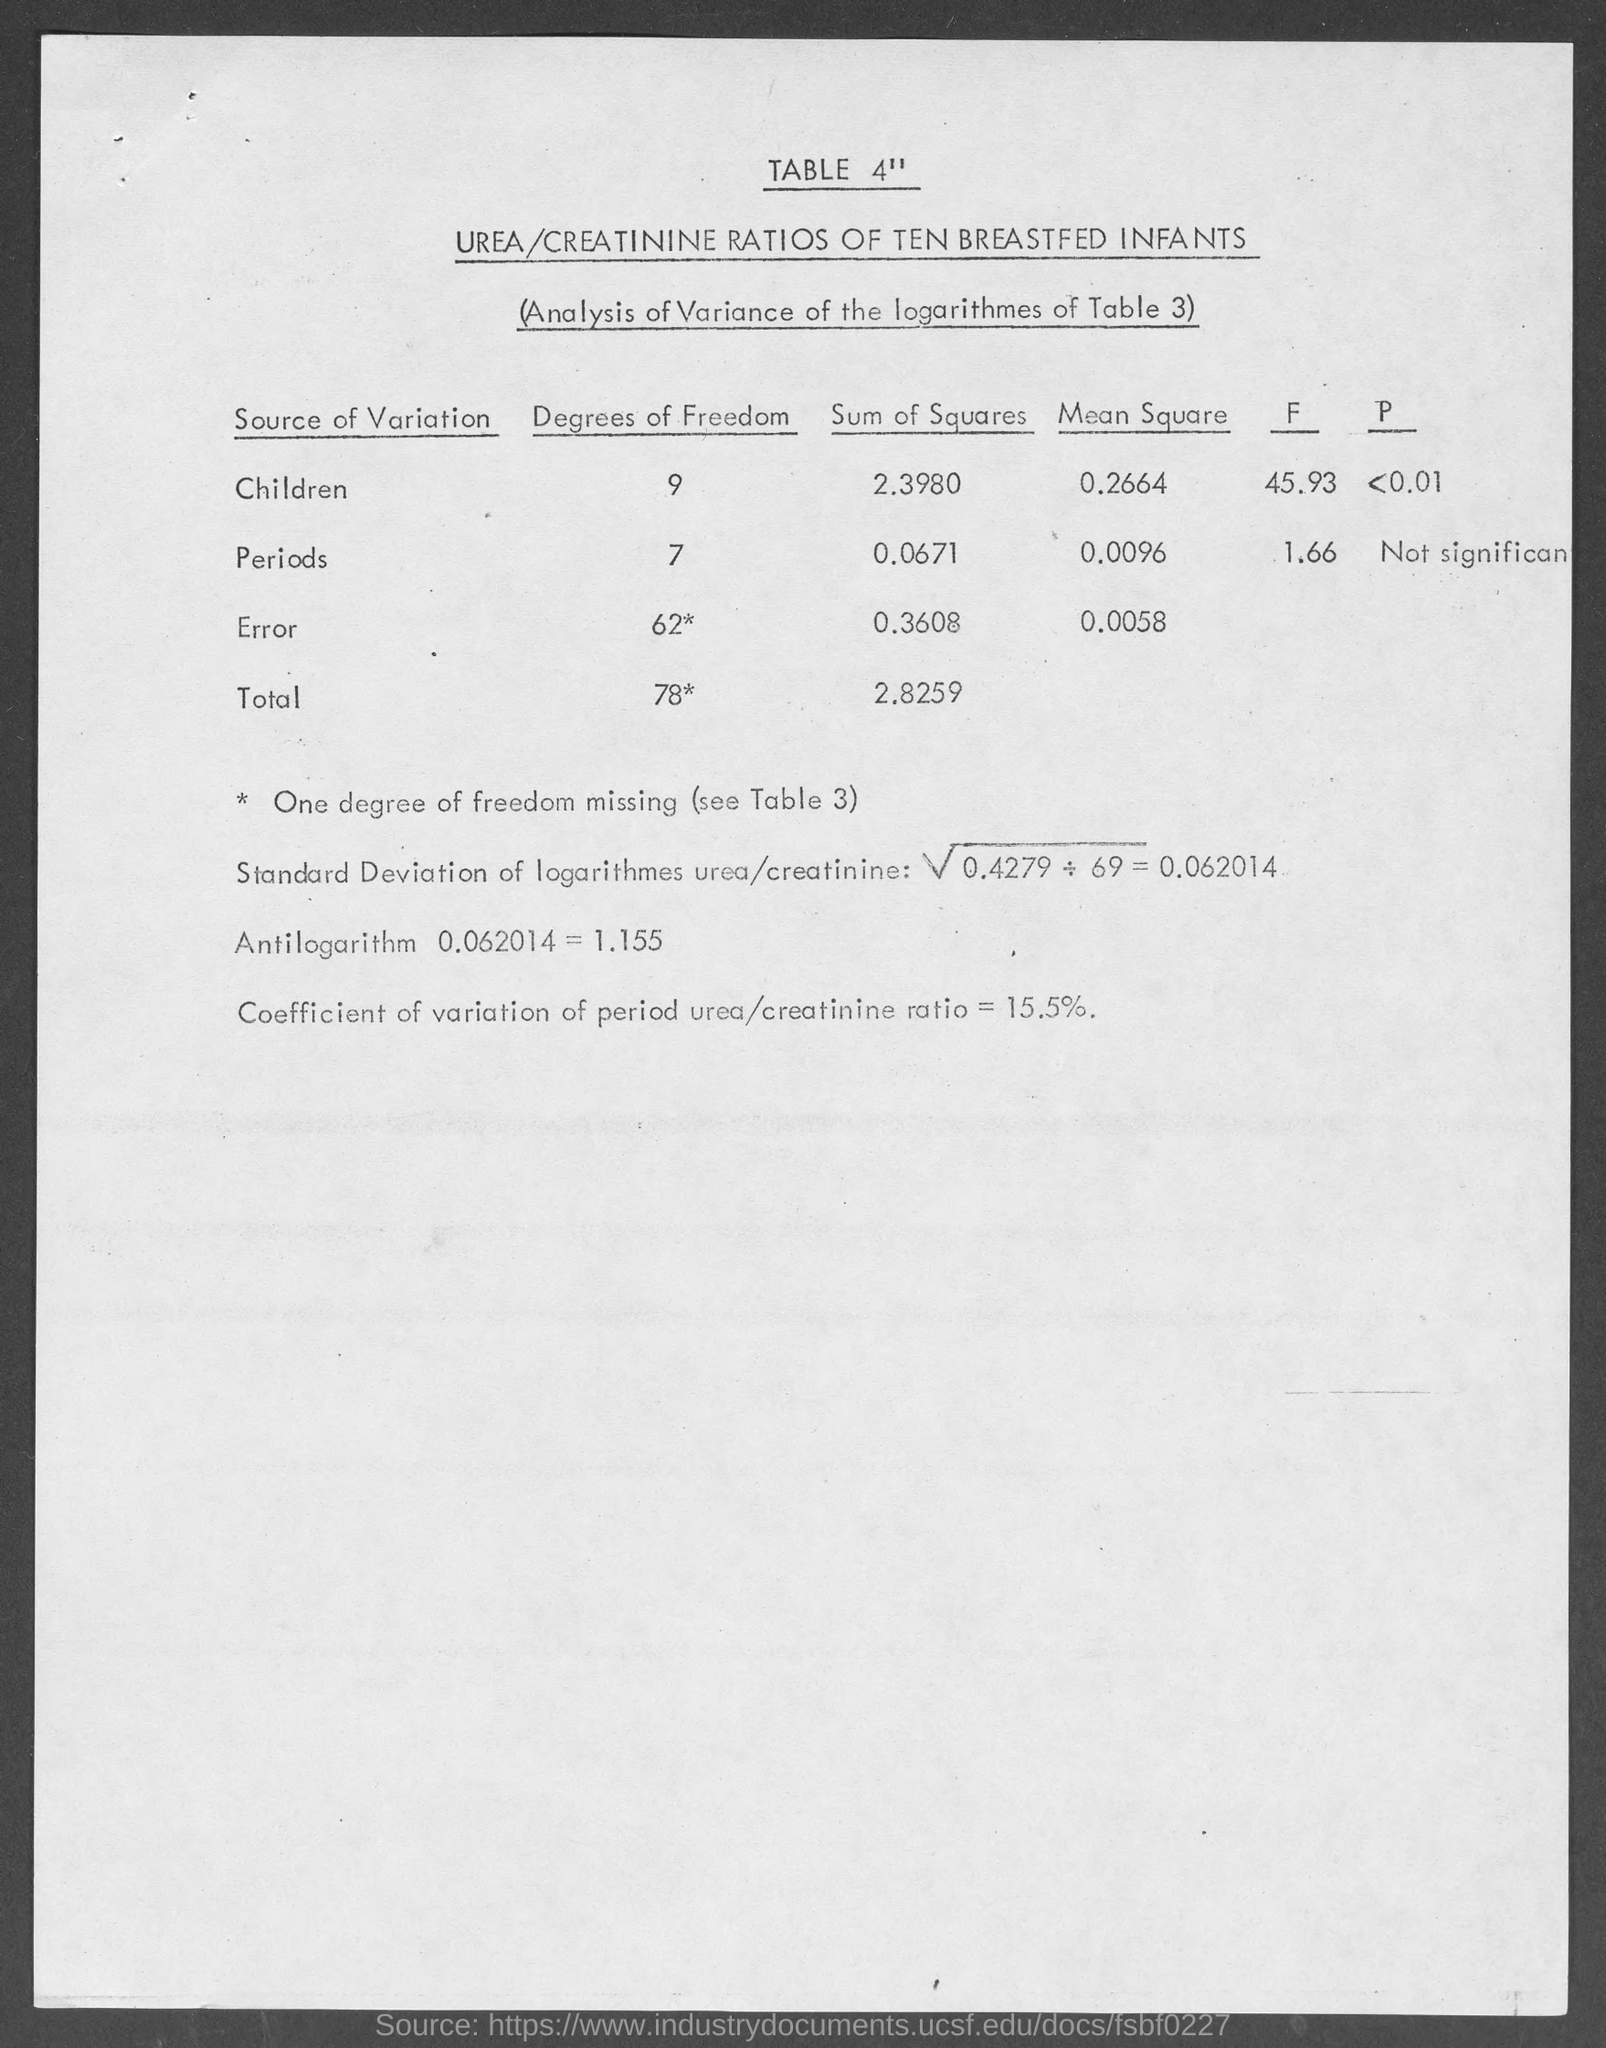What is the title of table 4"?
Provide a short and direct response. Urea/ Creatinine ratios of ten breastfed infants. What is the degrees of freedom for children ?
Keep it short and to the point. 9. What is the antilogarithm value of 0.062014 ?
Offer a terse response. 1.155. What is the coefficient of variation of period urea/ creatinine ratio?
Your response must be concise. 15.5%. 